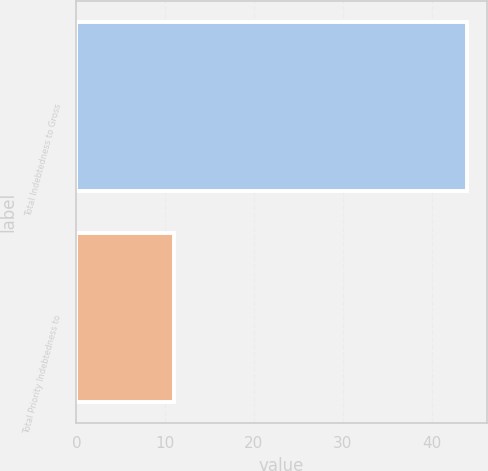<chart> <loc_0><loc_0><loc_500><loc_500><bar_chart><fcel>Total Indebtedness to Gross<fcel>Total Priority Indebtedness to<nl><fcel>44<fcel>11<nl></chart> 